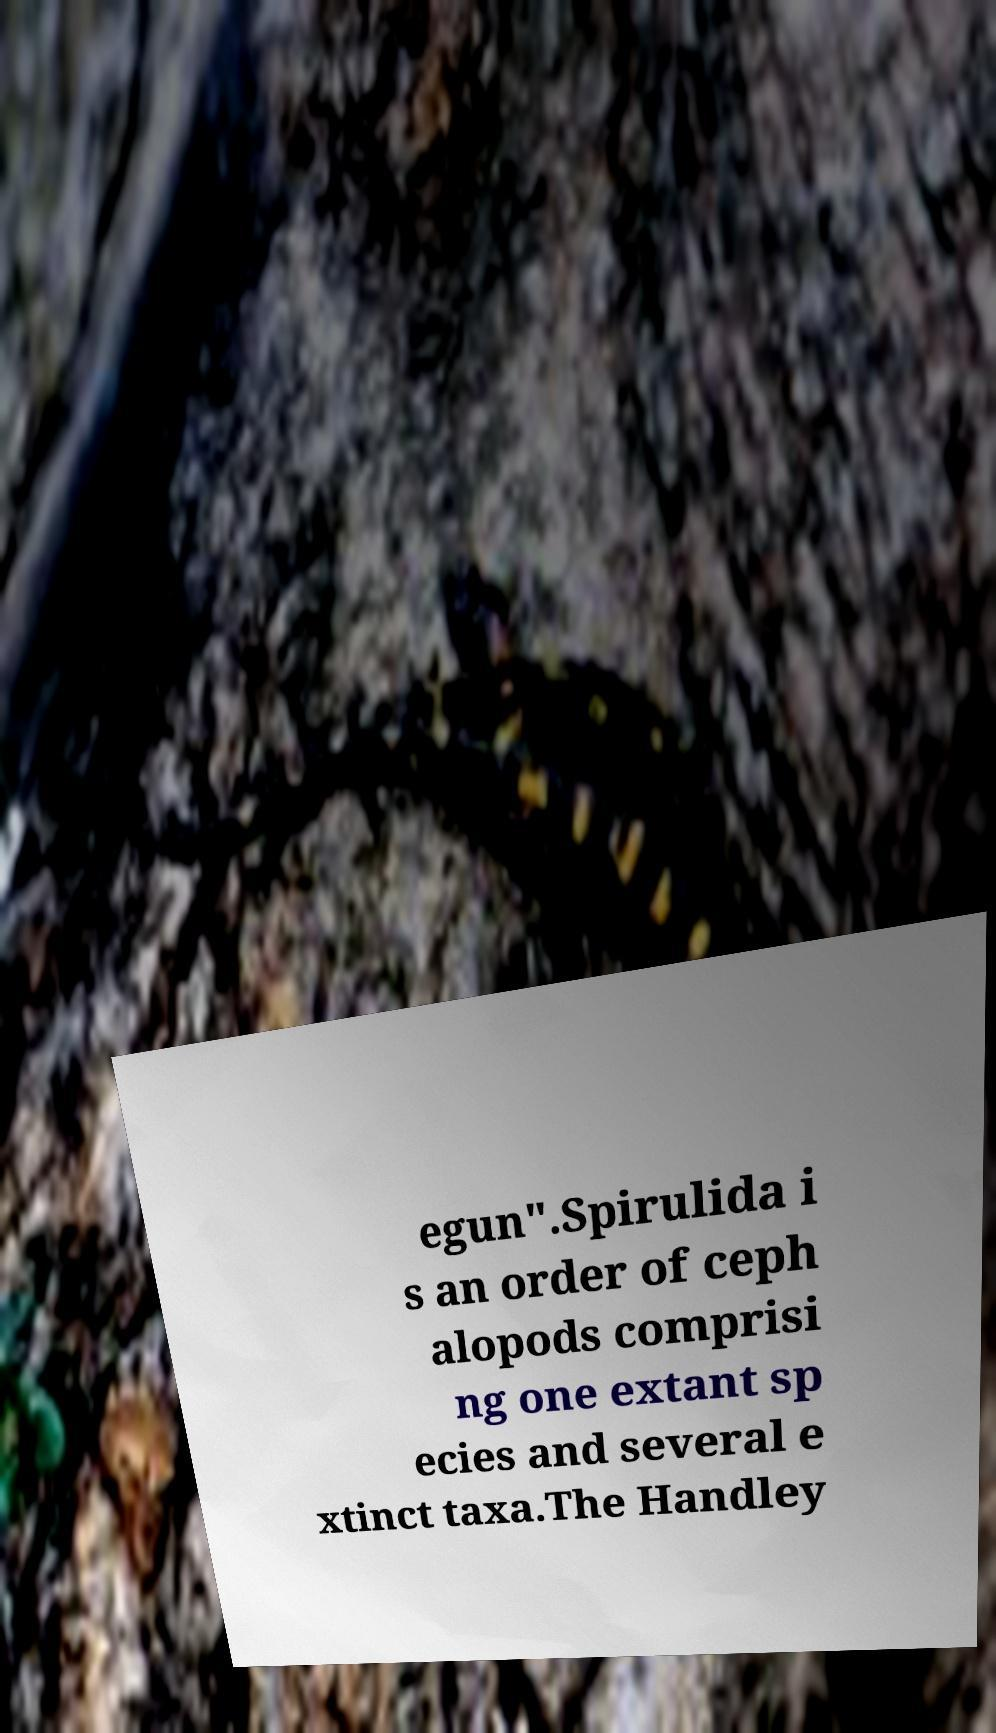Could you extract and type out the text from this image? egun".Spirulida i s an order of ceph alopods comprisi ng one extant sp ecies and several e xtinct taxa.The Handley 